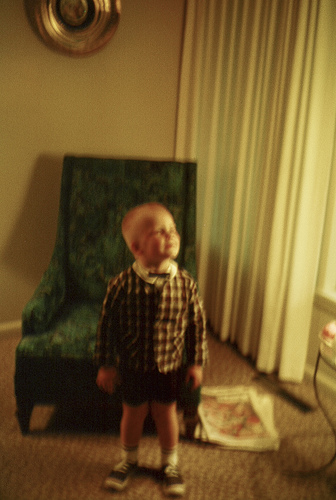<image>
Can you confirm if the boy is under the drapes? No. The boy is not positioned under the drapes. The vertical relationship between these objects is different. 